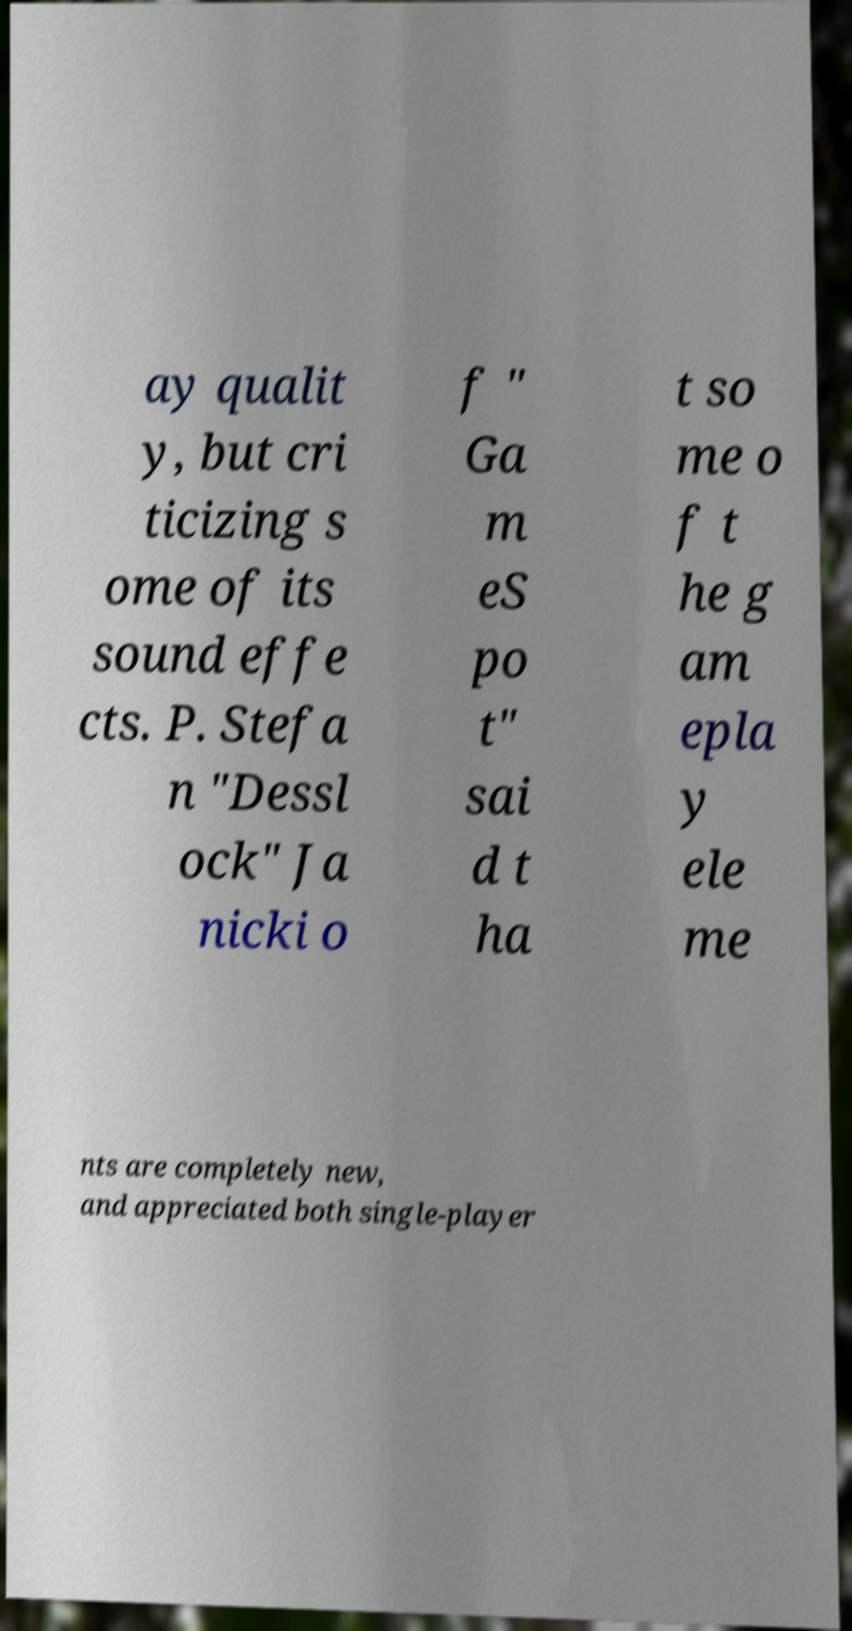What messages or text are displayed in this image? I need them in a readable, typed format. ay qualit y, but cri ticizing s ome of its sound effe cts. P. Stefa n "Dessl ock" Ja nicki o f " Ga m eS po t" sai d t ha t so me o f t he g am epla y ele me nts are completely new, and appreciated both single-player 